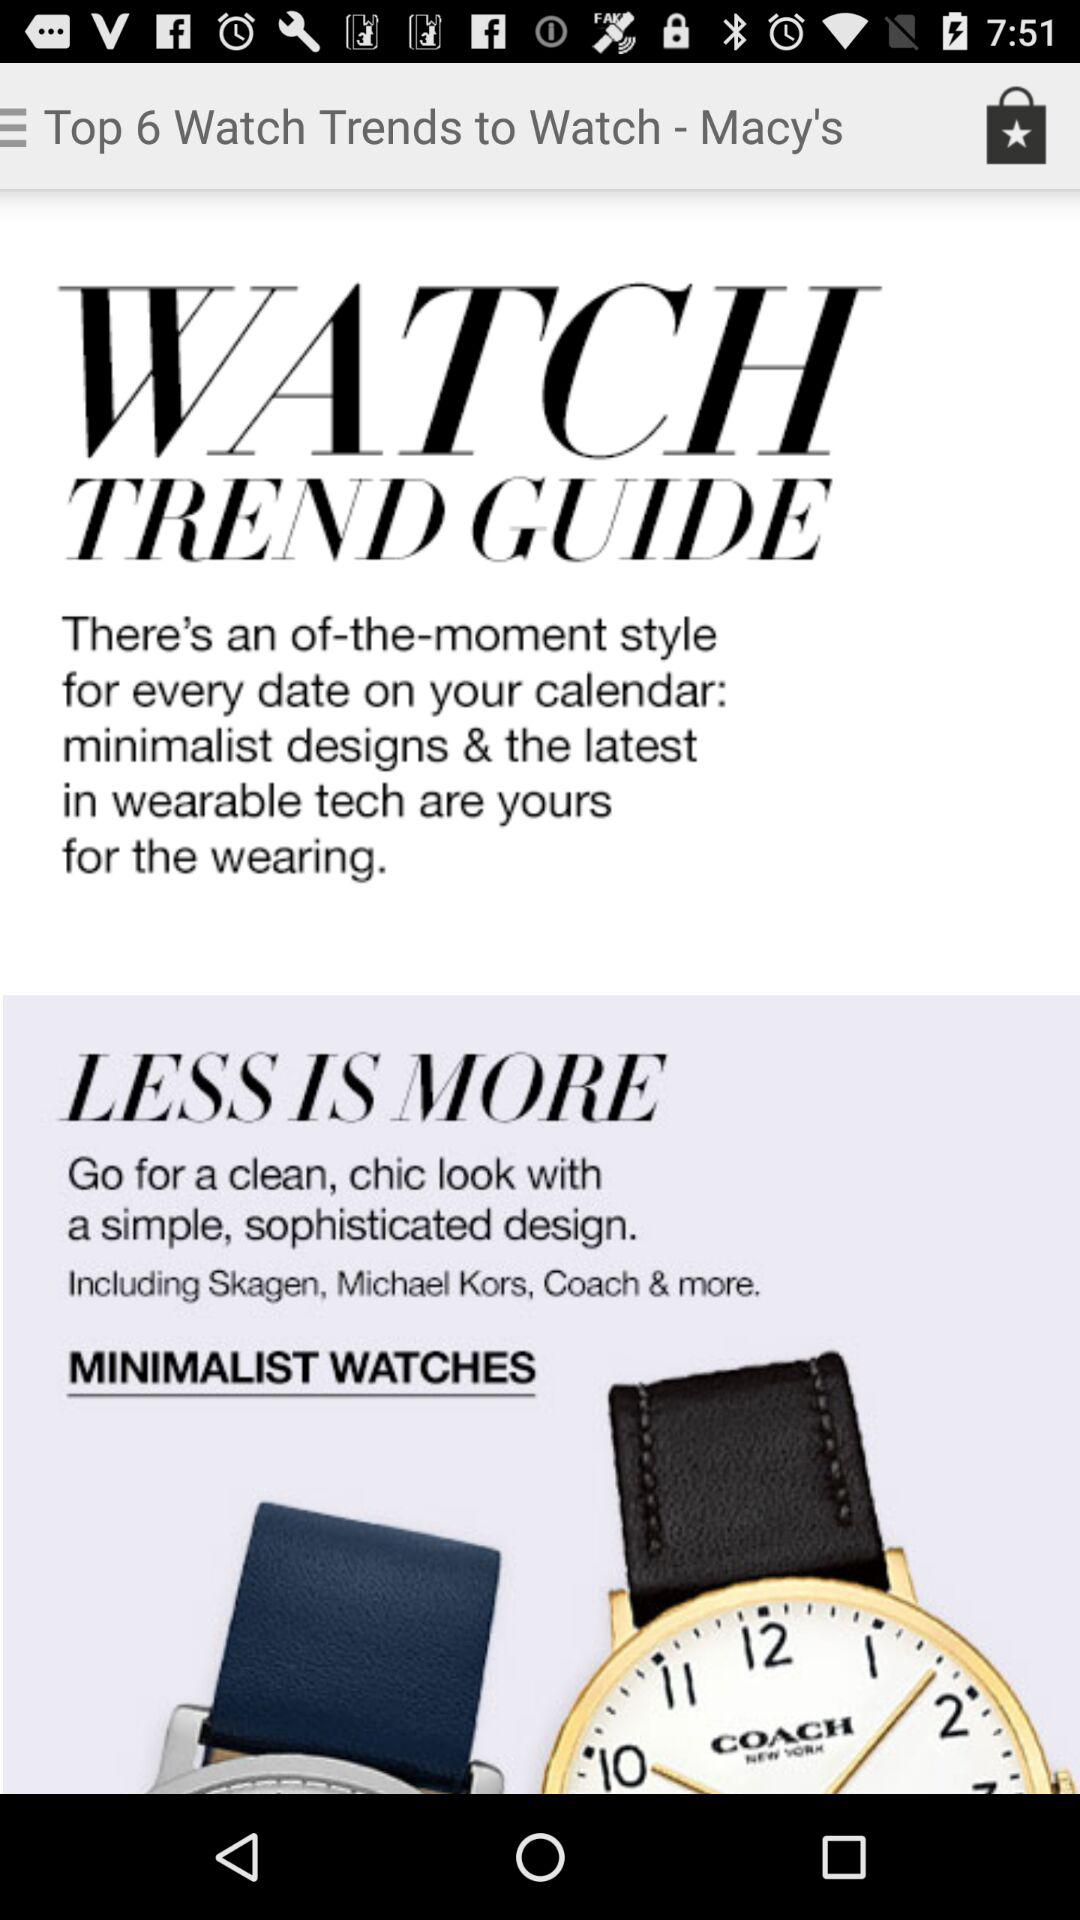Are there any sports watches trending?
When the provided information is insufficient, respond with <no answer>. <no answer> 